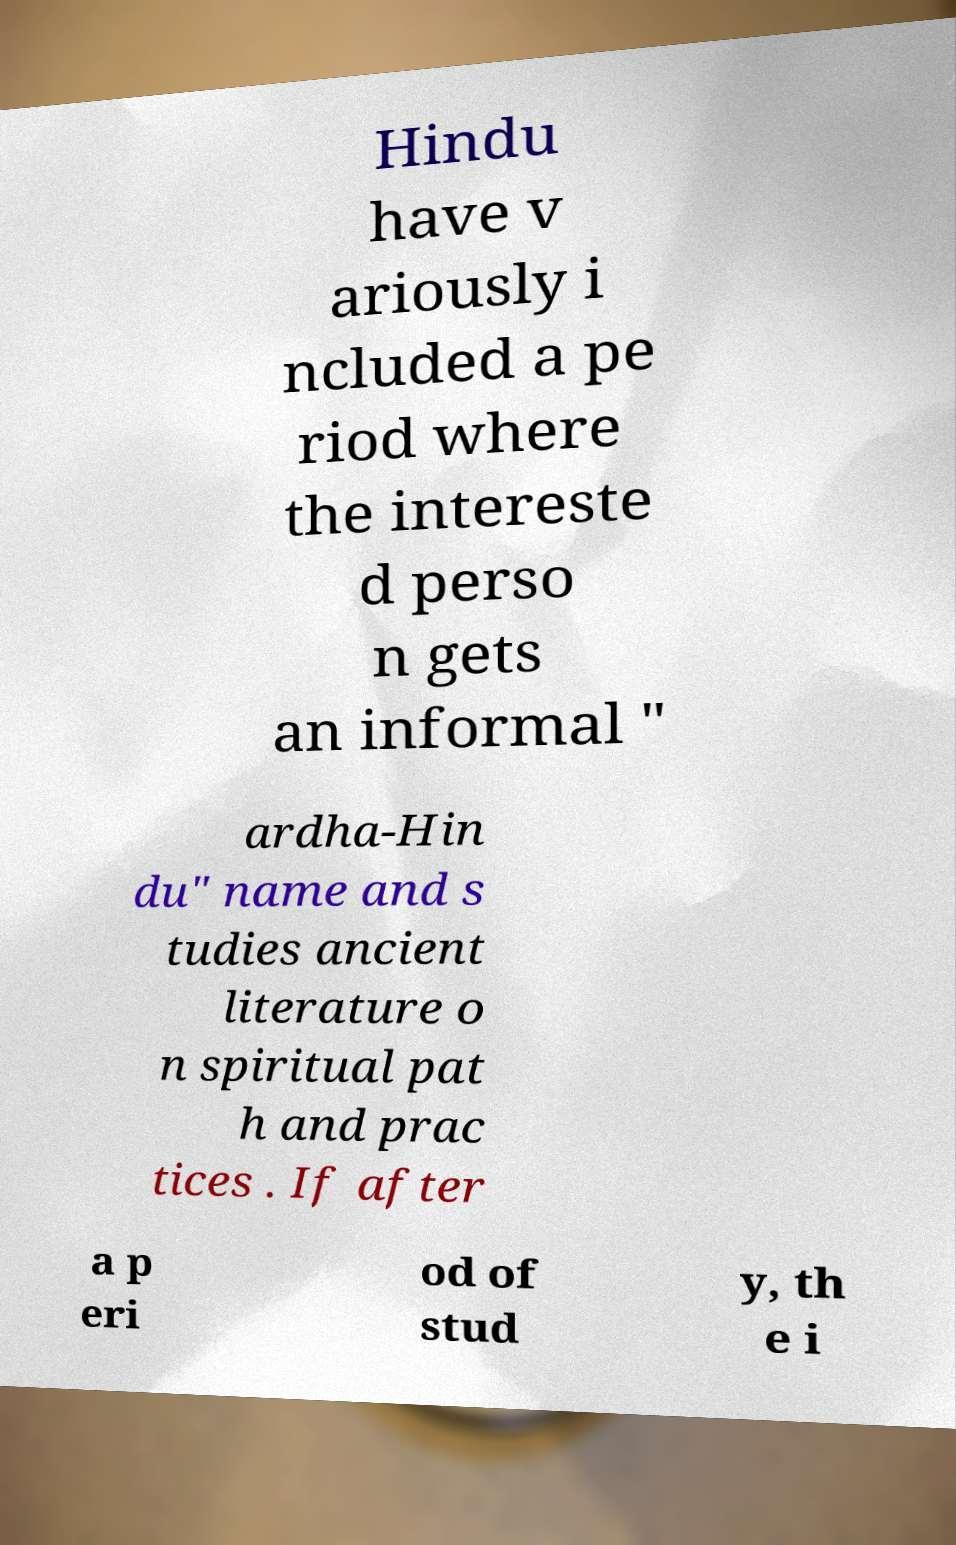For documentation purposes, I need the text within this image transcribed. Could you provide that? Hindu have v ariously i ncluded a pe riod where the intereste d perso n gets an informal " ardha-Hin du" name and s tudies ancient literature o n spiritual pat h and prac tices . If after a p eri od of stud y, th e i 